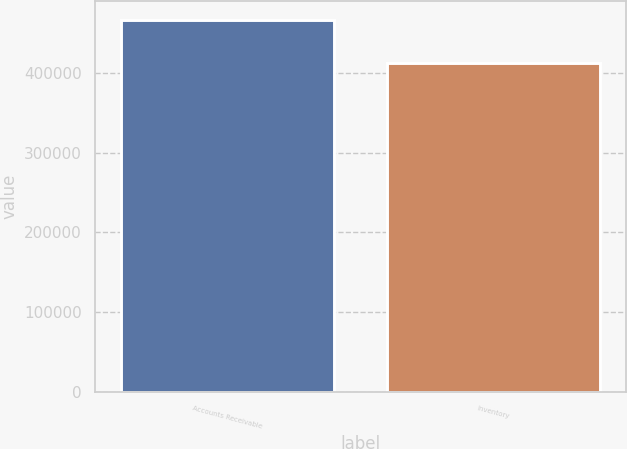Convert chart. <chart><loc_0><loc_0><loc_500><loc_500><bar_chart><fcel>Accounts Receivable<fcel>Inventory<nl><fcel>466527<fcel>412314<nl></chart> 